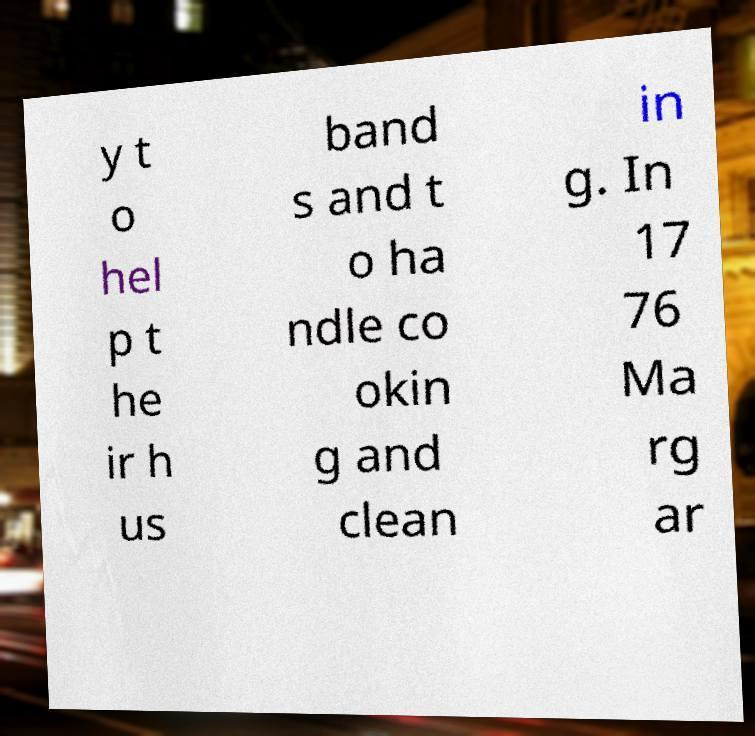Could you assist in decoding the text presented in this image and type it out clearly? y t o hel p t he ir h us band s and t o ha ndle co okin g and clean in g. In 17 76 Ma rg ar 